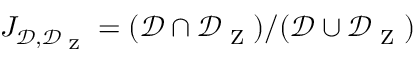<formula> <loc_0><loc_0><loc_500><loc_500>J _ { \mathcal { D } , \mathcal { D } _ { Z } } = ( \mathcal { D } \cap \mathcal { D } _ { Z } ) / ( \mathcal { D } \cup \mathcal { D } _ { Z } )</formula> 